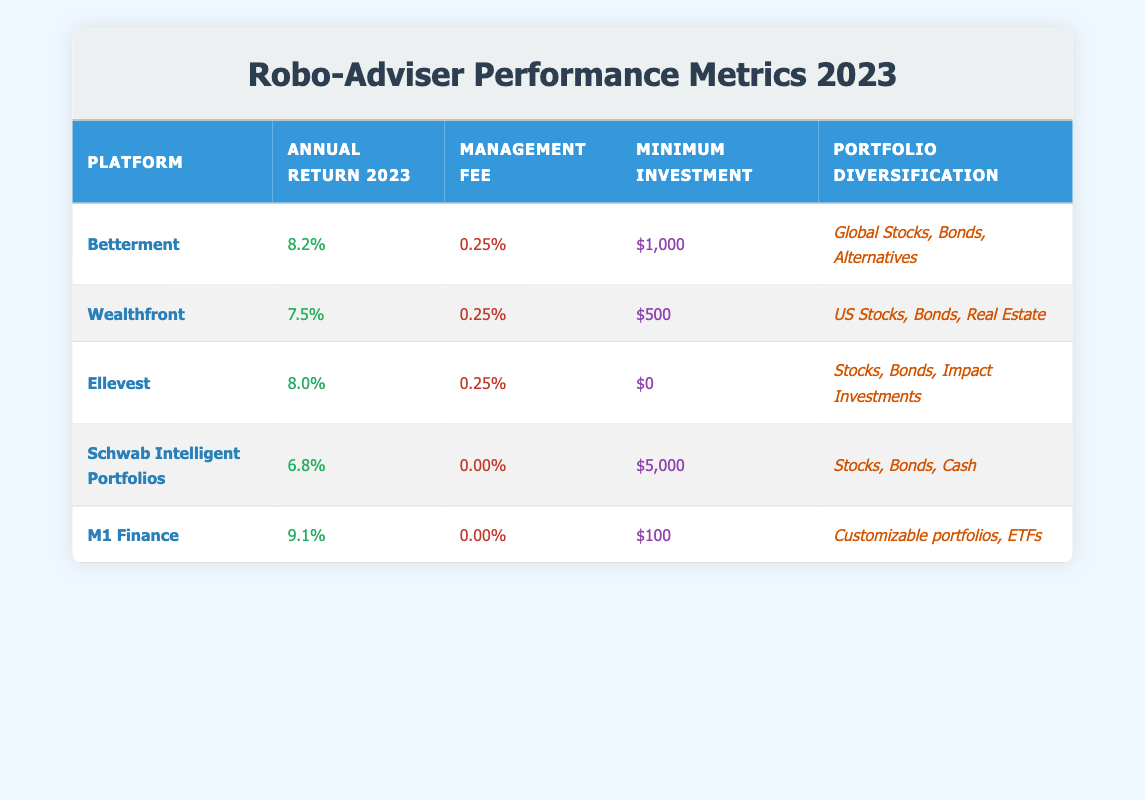What is the management fee for M1 Finance? The management fee for M1 Finance is listed in the table under the "Management Fee" column. According to the table, M1 Finance has a management fee of 0.00%.
Answer: 0.00% Which robo-adviser has the highest annual return in 2023? By comparing the "Annual Return 2023" values in the table, M1 Finance has the highest return of 9.1%.
Answer: M1 Finance Is the minimum investment for Ellevest greater than that of Wealthfront? The minimum investment for Ellevest is $0, while for Wealthfront it is $500. Since $0 is not greater than $500, the statement is false.
Answer: No What is the average annual return of all robo-advisers listed? To find the average annual return, we add all annual returns: (8.2 + 7.5 + 8.0 + 6.8 + 9.1) = 39.6 and divide by the number of platforms (5), giving us 39.6 / 5 = 7.92%.
Answer: 7.92% Which platforms have a management fee of 0.25%? The management fee of 0.25% appears in the table for Betterment, Wealthfront, and Ellevest. This is found under the "Management Fee" column.
Answer: Betterment, Wealthfront, Ellevest What is the difference in minimum investment between Schwab Intelligent Portfolios and M1 Finance? The minimum investment for Schwab Intelligent Portfolios is $5,000, and for M1 Finance, it is $100. The difference is $5,000 - $100 = $4,900.
Answer: $4,900 Does any platform have a minimum investment of exactly $100? Checking the "Minimum Investment" column, M1 Finance has a minimum investment of $100. Thus, the answer is true.
Answer: Yes Which platform offers the most diverse portfolio according to the table? To determine the platform with the most diverse portfolio, we can evaluate the descriptions in the "Portfolio Diversification" column. M1 Finance offers customizable portfolios, which can be seen as the most diverse option available.
Answer: M1 Finance 